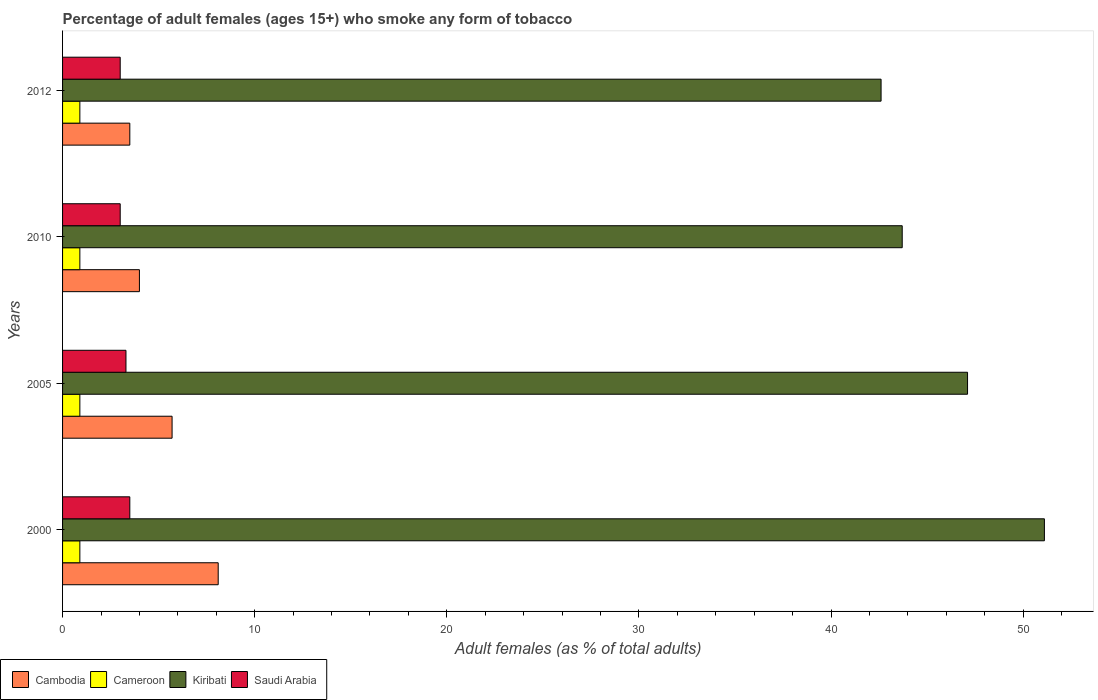Are the number of bars per tick equal to the number of legend labels?
Offer a very short reply. Yes. How many bars are there on the 1st tick from the bottom?
Keep it short and to the point. 4. In how many cases, is the number of bars for a given year not equal to the number of legend labels?
Offer a terse response. 0. What is the percentage of adult females who smoke in Kiribati in 2000?
Your answer should be compact. 51.1. Across all years, what is the maximum percentage of adult females who smoke in Kiribati?
Your answer should be very brief. 51.1. Across all years, what is the minimum percentage of adult females who smoke in Kiribati?
Keep it short and to the point. 42.6. In which year was the percentage of adult females who smoke in Cambodia maximum?
Make the answer very short. 2000. What is the total percentage of adult females who smoke in Kiribati in the graph?
Provide a succinct answer. 184.5. What is the difference between the percentage of adult females who smoke in Cameroon in 2005 and the percentage of adult females who smoke in Kiribati in 2012?
Your answer should be compact. -41.7. What is the average percentage of adult females who smoke in Cambodia per year?
Keep it short and to the point. 5.33. In the year 2005, what is the difference between the percentage of adult females who smoke in Kiribati and percentage of adult females who smoke in Cambodia?
Your answer should be very brief. 41.4. In how many years, is the percentage of adult females who smoke in Cambodia greater than 10 %?
Provide a short and direct response. 0. Is the percentage of adult females who smoke in Cambodia in 2000 less than that in 2005?
Your answer should be very brief. No. Is the difference between the percentage of adult females who smoke in Kiribati in 2005 and 2010 greater than the difference between the percentage of adult females who smoke in Cambodia in 2005 and 2010?
Offer a very short reply. Yes. What is the difference between the highest and the second highest percentage of adult females who smoke in Kiribati?
Offer a terse response. 4. What does the 2nd bar from the top in 2000 represents?
Your answer should be very brief. Kiribati. What does the 1st bar from the bottom in 2010 represents?
Your answer should be compact. Cambodia. Is it the case that in every year, the sum of the percentage of adult females who smoke in Saudi Arabia and percentage of adult females who smoke in Kiribati is greater than the percentage of adult females who smoke in Cameroon?
Your response must be concise. Yes. How many bars are there?
Make the answer very short. 16. How many years are there in the graph?
Provide a short and direct response. 4. What is the difference between two consecutive major ticks on the X-axis?
Your answer should be compact. 10. Does the graph contain any zero values?
Make the answer very short. No. Does the graph contain grids?
Provide a succinct answer. No. Where does the legend appear in the graph?
Provide a succinct answer. Bottom left. How are the legend labels stacked?
Offer a terse response. Horizontal. What is the title of the graph?
Offer a very short reply. Percentage of adult females (ages 15+) who smoke any form of tobacco. What is the label or title of the X-axis?
Provide a succinct answer. Adult females (as % of total adults). What is the Adult females (as % of total adults) of Cambodia in 2000?
Your response must be concise. 8.1. What is the Adult females (as % of total adults) in Cameroon in 2000?
Offer a terse response. 0.9. What is the Adult females (as % of total adults) of Kiribati in 2000?
Give a very brief answer. 51.1. What is the Adult females (as % of total adults) in Cambodia in 2005?
Your response must be concise. 5.7. What is the Adult females (as % of total adults) in Kiribati in 2005?
Provide a succinct answer. 47.1. What is the Adult females (as % of total adults) in Saudi Arabia in 2005?
Make the answer very short. 3.3. What is the Adult females (as % of total adults) in Cameroon in 2010?
Offer a very short reply. 0.9. What is the Adult females (as % of total adults) of Kiribati in 2010?
Your answer should be compact. 43.7. What is the Adult females (as % of total adults) in Cambodia in 2012?
Give a very brief answer. 3.5. What is the Adult females (as % of total adults) in Kiribati in 2012?
Keep it short and to the point. 42.6. What is the Adult females (as % of total adults) of Saudi Arabia in 2012?
Provide a succinct answer. 3. Across all years, what is the maximum Adult females (as % of total adults) in Cambodia?
Your response must be concise. 8.1. Across all years, what is the maximum Adult females (as % of total adults) in Kiribati?
Provide a short and direct response. 51.1. Across all years, what is the minimum Adult females (as % of total adults) in Cameroon?
Your answer should be very brief. 0.9. Across all years, what is the minimum Adult females (as % of total adults) of Kiribati?
Keep it short and to the point. 42.6. Across all years, what is the minimum Adult females (as % of total adults) of Saudi Arabia?
Provide a succinct answer. 3. What is the total Adult females (as % of total adults) of Cambodia in the graph?
Ensure brevity in your answer.  21.3. What is the total Adult females (as % of total adults) in Cameroon in the graph?
Offer a very short reply. 3.6. What is the total Adult females (as % of total adults) of Kiribati in the graph?
Provide a succinct answer. 184.5. What is the difference between the Adult females (as % of total adults) in Cameroon in 2000 and that in 2005?
Your answer should be compact. 0. What is the difference between the Adult females (as % of total adults) of Kiribati in 2000 and that in 2005?
Provide a succinct answer. 4. What is the difference between the Adult females (as % of total adults) of Cameroon in 2000 and that in 2012?
Your answer should be compact. 0. What is the difference between the Adult females (as % of total adults) of Kiribati in 2005 and that in 2010?
Offer a very short reply. 3.4. What is the difference between the Adult females (as % of total adults) of Cameroon in 2005 and that in 2012?
Give a very brief answer. 0. What is the difference between the Adult females (as % of total adults) in Saudi Arabia in 2005 and that in 2012?
Your response must be concise. 0.3. What is the difference between the Adult females (as % of total adults) in Cameroon in 2010 and that in 2012?
Make the answer very short. 0. What is the difference between the Adult females (as % of total adults) of Cambodia in 2000 and the Adult females (as % of total adults) of Cameroon in 2005?
Your response must be concise. 7.2. What is the difference between the Adult females (as % of total adults) of Cambodia in 2000 and the Adult females (as % of total adults) of Kiribati in 2005?
Offer a terse response. -39. What is the difference between the Adult females (as % of total adults) in Cameroon in 2000 and the Adult females (as % of total adults) in Kiribati in 2005?
Give a very brief answer. -46.2. What is the difference between the Adult females (as % of total adults) in Cameroon in 2000 and the Adult females (as % of total adults) in Saudi Arabia in 2005?
Give a very brief answer. -2.4. What is the difference between the Adult females (as % of total adults) of Kiribati in 2000 and the Adult females (as % of total adults) of Saudi Arabia in 2005?
Offer a very short reply. 47.8. What is the difference between the Adult females (as % of total adults) in Cambodia in 2000 and the Adult females (as % of total adults) in Cameroon in 2010?
Provide a short and direct response. 7.2. What is the difference between the Adult females (as % of total adults) of Cambodia in 2000 and the Adult females (as % of total adults) of Kiribati in 2010?
Make the answer very short. -35.6. What is the difference between the Adult females (as % of total adults) in Cambodia in 2000 and the Adult females (as % of total adults) in Saudi Arabia in 2010?
Give a very brief answer. 5.1. What is the difference between the Adult females (as % of total adults) of Cameroon in 2000 and the Adult females (as % of total adults) of Kiribati in 2010?
Give a very brief answer. -42.8. What is the difference between the Adult females (as % of total adults) in Kiribati in 2000 and the Adult females (as % of total adults) in Saudi Arabia in 2010?
Keep it short and to the point. 48.1. What is the difference between the Adult females (as % of total adults) in Cambodia in 2000 and the Adult females (as % of total adults) in Cameroon in 2012?
Make the answer very short. 7.2. What is the difference between the Adult females (as % of total adults) in Cambodia in 2000 and the Adult females (as % of total adults) in Kiribati in 2012?
Your answer should be very brief. -34.5. What is the difference between the Adult females (as % of total adults) in Cameroon in 2000 and the Adult females (as % of total adults) in Kiribati in 2012?
Provide a short and direct response. -41.7. What is the difference between the Adult females (as % of total adults) in Kiribati in 2000 and the Adult females (as % of total adults) in Saudi Arabia in 2012?
Your answer should be very brief. 48.1. What is the difference between the Adult females (as % of total adults) of Cambodia in 2005 and the Adult females (as % of total adults) of Cameroon in 2010?
Your answer should be compact. 4.8. What is the difference between the Adult females (as % of total adults) of Cambodia in 2005 and the Adult females (as % of total adults) of Kiribati in 2010?
Your response must be concise. -38. What is the difference between the Adult females (as % of total adults) of Cameroon in 2005 and the Adult females (as % of total adults) of Kiribati in 2010?
Offer a very short reply. -42.8. What is the difference between the Adult females (as % of total adults) of Kiribati in 2005 and the Adult females (as % of total adults) of Saudi Arabia in 2010?
Your answer should be very brief. 44.1. What is the difference between the Adult females (as % of total adults) of Cambodia in 2005 and the Adult females (as % of total adults) of Kiribati in 2012?
Your answer should be compact. -36.9. What is the difference between the Adult females (as % of total adults) of Cameroon in 2005 and the Adult females (as % of total adults) of Kiribati in 2012?
Ensure brevity in your answer.  -41.7. What is the difference between the Adult females (as % of total adults) of Kiribati in 2005 and the Adult females (as % of total adults) of Saudi Arabia in 2012?
Your answer should be compact. 44.1. What is the difference between the Adult females (as % of total adults) of Cambodia in 2010 and the Adult females (as % of total adults) of Cameroon in 2012?
Make the answer very short. 3.1. What is the difference between the Adult females (as % of total adults) of Cambodia in 2010 and the Adult females (as % of total adults) of Kiribati in 2012?
Your answer should be very brief. -38.6. What is the difference between the Adult females (as % of total adults) in Cambodia in 2010 and the Adult females (as % of total adults) in Saudi Arabia in 2012?
Your answer should be very brief. 1. What is the difference between the Adult females (as % of total adults) of Cameroon in 2010 and the Adult females (as % of total adults) of Kiribati in 2012?
Your answer should be compact. -41.7. What is the difference between the Adult females (as % of total adults) in Cameroon in 2010 and the Adult females (as % of total adults) in Saudi Arabia in 2012?
Your answer should be compact. -2.1. What is the difference between the Adult females (as % of total adults) in Kiribati in 2010 and the Adult females (as % of total adults) in Saudi Arabia in 2012?
Your answer should be very brief. 40.7. What is the average Adult females (as % of total adults) in Cambodia per year?
Provide a short and direct response. 5.33. What is the average Adult females (as % of total adults) in Kiribati per year?
Your response must be concise. 46.12. What is the average Adult females (as % of total adults) in Saudi Arabia per year?
Ensure brevity in your answer.  3.2. In the year 2000, what is the difference between the Adult females (as % of total adults) of Cambodia and Adult females (as % of total adults) of Kiribati?
Provide a short and direct response. -43. In the year 2000, what is the difference between the Adult females (as % of total adults) in Cameroon and Adult females (as % of total adults) in Kiribati?
Your answer should be very brief. -50.2. In the year 2000, what is the difference between the Adult females (as % of total adults) of Cameroon and Adult females (as % of total adults) of Saudi Arabia?
Your response must be concise. -2.6. In the year 2000, what is the difference between the Adult females (as % of total adults) of Kiribati and Adult females (as % of total adults) of Saudi Arabia?
Your response must be concise. 47.6. In the year 2005, what is the difference between the Adult females (as % of total adults) of Cambodia and Adult females (as % of total adults) of Kiribati?
Ensure brevity in your answer.  -41.4. In the year 2005, what is the difference between the Adult females (as % of total adults) of Cameroon and Adult females (as % of total adults) of Kiribati?
Your answer should be compact. -46.2. In the year 2005, what is the difference between the Adult females (as % of total adults) in Kiribati and Adult females (as % of total adults) in Saudi Arabia?
Make the answer very short. 43.8. In the year 2010, what is the difference between the Adult females (as % of total adults) in Cambodia and Adult females (as % of total adults) in Cameroon?
Provide a succinct answer. 3.1. In the year 2010, what is the difference between the Adult females (as % of total adults) in Cambodia and Adult females (as % of total adults) in Kiribati?
Your response must be concise. -39.7. In the year 2010, what is the difference between the Adult females (as % of total adults) in Cameroon and Adult females (as % of total adults) in Kiribati?
Make the answer very short. -42.8. In the year 2010, what is the difference between the Adult females (as % of total adults) in Cameroon and Adult females (as % of total adults) in Saudi Arabia?
Give a very brief answer. -2.1. In the year 2010, what is the difference between the Adult females (as % of total adults) of Kiribati and Adult females (as % of total adults) of Saudi Arabia?
Offer a very short reply. 40.7. In the year 2012, what is the difference between the Adult females (as % of total adults) of Cambodia and Adult females (as % of total adults) of Cameroon?
Offer a very short reply. 2.6. In the year 2012, what is the difference between the Adult females (as % of total adults) in Cambodia and Adult females (as % of total adults) in Kiribati?
Make the answer very short. -39.1. In the year 2012, what is the difference between the Adult females (as % of total adults) in Cameroon and Adult females (as % of total adults) in Kiribati?
Your answer should be compact. -41.7. In the year 2012, what is the difference between the Adult females (as % of total adults) of Cameroon and Adult females (as % of total adults) of Saudi Arabia?
Offer a very short reply. -2.1. In the year 2012, what is the difference between the Adult females (as % of total adults) in Kiribati and Adult females (as % of total adults) in Saudi Arabia?
Your answer should be compact. 39.6. What is the ratio of the Adult females (as % of total adults) of Cambodia in 2000 to that in 2005?
Give a very brief answer. 1.42. What is the ratio of the Adult females (as % of total adults) in Kiribati in 2000 to that in 2005?
Ensure brevity in your answer.  1.08. What is the ratio of the Adult females (as % of total adults) in Saudi Arabia in 2000 to that in 2005?
Offer a terse response. 1.06. What is the ratio of the Adult females (as % of total adults) of Cambodia in 2000 to that in 2010?
Offer a terse response. 2.02. What is the ratio of the Adult females (as % of total adults) in Cameroon in 2000 to that in 2010?
Ensure brevity in your answer.  1. What is the ratio of the Adult females (as % of total adults) in Kiribati in 2000 to that in 2010?
Keep it short and to the point. 1.17. What is the ratio of the Adult females (as % of total adults) in Saudi Arabia in 2000 to that in 2010?
Ensure brevity in your answer.  1.17. What is the ratio of the Adult females (as % of total adults) of Cambodia in 2000 to that in 2012?
Give a very brief answer. 2.31. What is the ratio of the Adult females (as % of total adults) of Kiribati in 2000 to that in 2012?
Give a very brief answer. 1.2. What is the ratio of the Adult females (as % of total adults) in Cambodia in 2005 to that in 2010?
Your answer should be very brief. 1.43. What is the ratio of the Adult females (as % of total adults) in Cameroon in 2005 to that in 2010?
Your response must be concise. 1. What is the ratio of the Adult females (as % of total adults) in Kiribati in 2005 to that in 2010?
Provide a short and direct response. 1.08. What is the ratio of the Adult females (as % of total adults) in Cambodia in 2005 to that in 2012?
Make the answer very short. 1.63. What is the ratio of the Adult females (as % of total adults) of Kiribati in 2005 to that in 2012?
Your response must be concise. 1.11. What is the ratio of the Adult females (as % of total adults) of Saudi Arabia in 2005 to that in 2012?
Offer a very short reply. 1.1. What is the ratio of the Adult females (as % of total adults) of Kiribati in 2010 to that in 2012?
Your answer should be very brief. 1.03. What is the ratio of the Adult females (as % of total adults) of Saudi Arabia in 2010 to that in 2012?
Keep it short and to the point. 1. What is the difference between the highest and the second highest Adult females (as % of total adults) of Cameroon?
Give a very brief answer. 0. What is the difference between the highest and the second highest Adult females (as % of total adults) of Saudi Arabia?
Offer a terse response. 0.2. What is the difference between the highest and the lowest Adult females (as % of total adults) of Cameroon?
Offer a terse response. 0. 